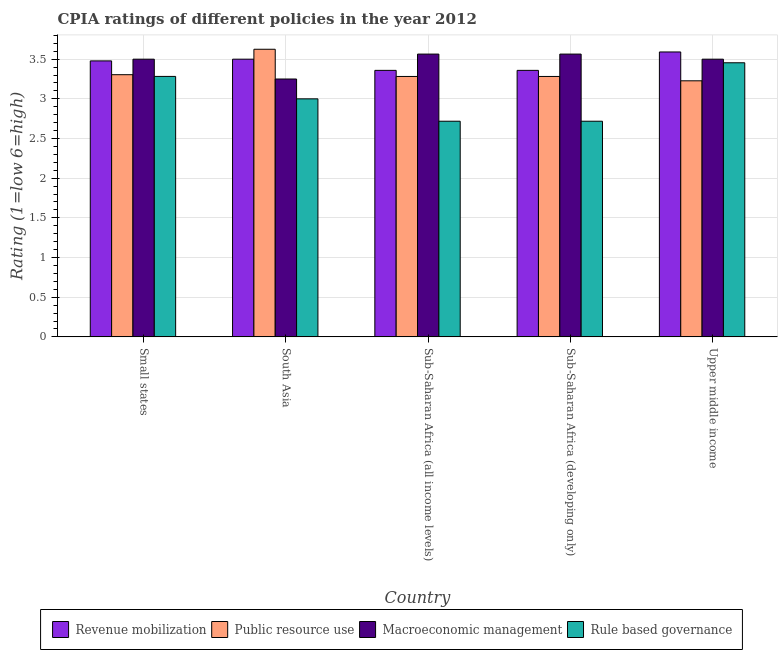How many different coloured bars are there?
Offer a very short reply. 4. How many groups of bars are there?
Ensure brevity in your answer.  5. Are the number of bars on each tick of the X-axis equal?
Make the answer very short. Yes. How many bars are there on the 2nd tick from the left?
Give a very brief answer. 4. What is the label of the 4th group of bars from the left?
Give a very brief answer. Sub-Saharan Africa (developing only). In how many cases, is the number of bars for a given country not equal to the number of legend labels?
Provide a short and direct response. 0. What is the cpia rating of macroeconomic management in Small states?
Make the answer very short. 3.5. Across all countries, what is the maximum cpia rating of macroeconomic management?
Your answer should be very brief. 3.56. Across all countries, what is the minimum cpia rating of revenue mobilization?
Your answer should be very brief. 3.36. In which country was the cpia rating of public resource use minimum?
Your answer should be compact. Upper middle income. What is the total cpia rating of macroeconomic management in the graph?
Keep it short and to the point. 17.38. What is the difference between the cpia rating of revenue mobilization in Small states and that in Sub-Saharan Africa (developing only)?
Your answer should be very brief. 0.12. What is the difference between the cpia rating of rule based governance in Small states and the cpia rating of public resource use in Sub-Saharan Africa (all income levels)?
Ensure brevity in your answer.  0. What is the average cpia rating of revenue mobilization per country?
Make the answer very short. 3.46. What is the ratio of the cpia rating of revenue mobilization in South Asia to that in Sub-Saharan Africa (developing only)?
Ensure brevity in your answer.  1.04. What is the difference between the highest and the second highest cpia rating of public resource use?
Provide a short and direct response. 0.32. What is the difference between the highest and the lowest cpia rating of public resource use?
Your answer should be very brief. 0.4. Is the sum of the cpia rating of rule based governance in South Asia and Upper middle income greater than the maximum cpia rating of macroeconomic management across all countries?
Provide a short and direct response. Yes. Is it the case that in every country, the sum of the cpia rating of public resource use and cpia rating of revenue mobilization is greater than the sum of cpia rating of rule based governance and cpia rating of macroeconomic management?
Provide a succinct answer. Yes. What does the 4th bar from the left in Sub-Saharan Africa (all income levels) represents?
Your answer should be very brief. Rule based governance. What does the 2nd bar from the right in South Asia represents?
Your response must be concise. Macroeconomic management. Is it the case that in every country, the sum of the cpia rating of revenue mobilization and cpia rating of public resource use is greater than the cpia rating of macroeconomic management?
Keep it short and to the point. Yes. How many bars are there?
Keep it short and to the point. 20. Are all the bars in the graph horizontal?
Provide a succinct answer. No. What is the title of the graph?
Your answer should be very brief. CPIA ratings of different policies in the year 2012. What is the label or title of the X-axis?
Your answer should be compact. Country. What is the Rating (1=low 6=high) in Revenue mobilization in Small states?
Give a very brief answer. 3.48. What is the Rating (1=low 6=high) in Public resource use in Small states?
Provide a short and direct response. 3.3. What is the Rating (1=low 6=high) of Rule based governance in Small states?
Your answer should be compact. 3.28. What is the Rating (1=low 6=high) in Revenue mobilization in South Asia?
Ensure brevity in your answer.  3.5. What is the Rating (1=low 6=high) in Public resource use in South Asia?
Your answer should be compact. 3.62. What is the Rating (1=low 6=high) of Macroeconomic management in South Asia?
Provide a short and direct response. 3.25. What is the Rating (1=low 6=high) of Revenue mobilization in Sub-Saharan Africa (all income levels)?
Your answer should be very brief. 3.36. What is the Rating (1=low 6=high) of Public resource use in Sub-Saharan Africa (all income levels)?
Offer a terse response. 3.28. What is the Rating (1=low 6=high) in Macroeconomic management in Sub-Saharan Africa (all income levels)?
Give a very brief answer. 3.56. What is the Rating (1=low 6=high) of Rule based governance in Sub-Saharan Africa (all income levels)?
Provide a short and direct response. 2.72. What is the Rating (1=low 6=high) of Revenue mobilization in Sub-Saharan Africa (developing only)?
Offer a very short reply. 3.36. What is the Rating (1=low 6=high) of Public resource use in Sub-Saharan Africa (developing only)?
Ensure brevity in your answer.  3.28. What is the Rating (1=low 6=high) in Macroeconomic management in Sub-Saharan Africa (developing only)?
Provide a short and direct response. 3.56. What is the Rating (1=low 6=high) in Rule based governance in Sub-Saharan Africa (developing only)?
Offer a very short reply. 2.72. What is the Rating (1=low 6=high) in Revenue mobilization in Upper middle income?
Provide a short and direct response. 3.59. What is the Rating (1=low 6=high) in Public resource use in Upper middle income?
Ensure brevity in your answer.  3.23. What is the Rating (1=low 6=high) of Rule based governance in Upper middle income?
Your response must be concise. 3.45. Across all countries, what is the maximum Rating (1=low 6=high) in Revenue mobilization?
Keep it short and to the point. 3.59. Across all countries, what is the maximum Rating (1=low 6=high) in Public resource use?
Ensure brevity in your answer.  3.62. Across all countries, what is the maximum Rating (1=low 6=high) in Macroeconomic management?
Offer a very short reply. 3.56. Across all countries, what is the maximum Rating (1=low 6=high) in Rule based governance?
Offer a terse response. 3.45. Across all countries, what is the minimum Rating (1=low 6=high) of Revenue mobilization?
Ensure brevity in your answer.  3.36. Across all countries, what is the minimum Rating (1=low 6=high) of Public resource use?
Make the answer very short. 3.23. Across all countries, what is the minimum Rating (1=low 6=high) in Rule based governance?
Your answer should be very brief. 2.72. What is the total Rating (1=low 6=high) of Revenue mobilization in the graph?
Make the answer very short. 17.29. What is the total Rating (1=low 6=high) of Public resource use in the graph?
Your answer should be compact. 16.72. What is the total Rating (1=low 6=high) of Macroeconomic management in the graph?
Your response must be concise. 17.38. What is the total Rating (1=low 6=high) in Rule based governance in the graph?
Keep it short and to the point. 15.17. What is the difference between the Rating (1=low 6=high) of Revenue mobilization in Small states and that in South Asia?
Ensure brevity in your answer.  -0.02. What is the difference between the Rating (1=low 6=high) in Public resource use in Small states and that in South Asia?
Ensure brevity in your answer.  -0.32. What is the difference between the Rating (1=low 6=high) of Rule based governance in Small states and that in South Asia?
Your answer should be compact. 0.28. What is the difference between the Rating (1=low 6=high) of Revenue mobilization in Small states and that in Sub-Saharan Africa (all income levels)?
Your response must be concise. 0.12. What is the difference between the Rating (1=low 6=high) in Public resource use in Small states and that in Sub-Saharan Africa (all income levels)?
Provide a succinct answer. 0.02. What is the difference between the Rating (1=low 6=high) of Macroeconomic management in Small states and that in Sub-Saharan Africa (all income levels)?
Your answer should be very brief. -0.06. What is the difference between the Rating (1=low 6=high) of Rule based governance in Small states and that in Sub-Saharan Africa (all income levels)?
Your answer should be compact. 0.56. What is the difference between the Rating (1=low 6=high) in Revenue mobilization in Small states and that in Sub-Saharan Africa (developing only)?
Your answer should be very brief. 0.12. What is the difference between the Rating (1=low 6=high) of Public resource use in Small states and that in Sub-Saharan Africa (developing only)?
Make the answer very short. 0.02. What is the difference between the Rating (1=low 6=high) of Macroeconomic management in Small states and that in Sub-Saharan Africa (developing only)?
Give a very brief answer. -0.06. What is the difference between the Rating (1=low 6=high) in Rule based governance in Small states and that in Sub-Saharan Africa (developing only)?
Keep it short and to the point. 0.56. What is the difference between the Rating (1=low 6=high) in Revenue mobilization in Small states and that in Upper middle income?
Your answer should be very brief. -0.11. What is the difference between the Rating (1=low 6=high) of Public resource use in Small states and that in Upper middle income?
Ensure brevity in your answer.  0.08. What is the difference between the Rating (1=low 6=high) in Macroeconomic management in Small states and that in Upper middle income?
Provide a short and direct response. 0. What is the difference between the Rating (1=low 6=high) in Rule based governance in Small states and that in Upper middle income?
Your answer should be very brief. -0.17. What is the difference between the Rating (1=low 6=high) of Revenue mobilization in South Asia and that in Sub-Saharan Africa (all income levels)?
Ensure brevity in your answer.  0.14. What is the difference between the Rating (1=low 6=high) in Public resource use in South Asia and that in Sub-Saharan Africa (all income levels)?
Offer a very short reply. 0.34. What is the difference between the Rating (1=low 6=high) in Macroeconomic management in South Asia and that in Sub-Saharan Africa (all income levels)?
Your answer should be compact. -0.31. What is the difference between the Rating (1=low 6=high) of Rule based governance in South Asia and that in Sub-Saharan Africa (all income levels)?
Offer a terse response. 0.28. What is the difference between the Rating (1=low 6=high) in Revenue mobilization in South Asia and that in Sub-Saharan Africa (developing only)?
Provide a succinct answer. 0.14. What is the difference between the Rating (1=low 6=high) in Public resource use in South Asia and that in Sub-Saharan Africa (developing only)?
Provide a short and direct response. 0.34. What is the difference between the Rating (1=low 6=high) in Macroeconomic management in South Asia and that in Sub-Saharan Africa (developing only)?
Make the answer very short. -0.31. What is the difference between the Rating (1=low 6=high) of Rule based governance in South Asia and that in Sub-Saharan Africa (developing only)?
Keep it short and to the point. 0.28. What is the difference between the Rating (1=low 6=high) in Revenue mobilization in South Asia and that in Upper middle income?
Provide a short and direct response. -0.09. What is the difference between the Rating (1=low 6=high) in Public resource use in South Asia and that in Upper middle income?
Ensure brevity in your answer.  0.4. What is the difference between the Rating (1=low 6=high) in Rule based governance in South Asia and that in Upper middle income?
Provide a short and direct response. -0.45. What is the difference between the Rating (1=low 6=high) in Revenue mobilization in Sub-Saharan Africa (all income levels) and that in Sub-Saharan Africa (developing only)?
Provide a succinct answer. 0. What is the difference between the Rating (1=low 6=high) in Public resource use in Sub-Saharan Africa (all income levels) and that in Sub-Saharan Africa (developing only)?
Provide a succinct answer. 0. What is the difference between the Rating (1=low 6=high) of Rule based governance in Sub-Saharan Africa (all income levels) and that in Sub-Saharan Africa (developing only)?
Make the answer very short. 0. What is the difference between the Rating (1=low 6=high) in Revenue mobilization in Sub-Saharan Africa (all income levels) and that in Upper middle income?
Make the answer very short. -0.23. What is the difference between the Rating (1=low 6=high) in Public resource use in Sub-Saharan Africa (all income levels) and that in Upper middle income?
Provide a succinct answer. 0.05. What is the difference between the Rating (1=low 6=high) in Macroeconomic management in Sub-Saharan Africa (all income levels) and that in Upper middle income?
Your answer should be very brief. 0.06. What is the difference between the Rating (1=low 6=high) of Rule based governance in Sub-Saharan Africa (all income levels) and that in Upper middle income?
Give a very brief answer. -0.74. What is the difference between the Rating (1=low 6=high) in Revenue mobilization in Sub-Saharan Africa (developing only) and that in Upper middle income?
Provide a short and direct response. -0.23. What is the difference between the Rating (1=low 6=high) in Public resource use in Sub-Saharan Africa (developing only) and that in Upper middle income?
Make the answer very short. 0.05. What is the difference between the Rating (1=low 6=high) in Macroeconomic management in Sub-Saharan Africa (developing only) and that in Upper middle income?
Provide a succinct answer. 0.06. What is the difference between the Rating (1=low 6=high) of Rule based governance in Sub-Saharan Africa (developing only) and that in Upper middle income?
Ensure brevity in your answer.  -0.74. What is the difference between the Rating (1=low 6=high) in Revenue mobilization in Small states and the Rating (1=low 6=high) in Public resource use in South Asia?
Your response must be concise. -0.15. What is the difference between the Rating (1=low 6=high) in Revenue mobilization in Small states and the Rating (1=low 6=high) in Macroeconomic management in South Asia?
Your answer should be compact. 0.23. What is the difference between the Rating (1=low 6=high) of Revenue mobilization in Small states and the Rating (1=low 6=high) of Rule based governance in South Asia?
Your answer should be very brief. 0.48. What is the difference between the Rating (1=low 6=high) of Public resource use in Small states and the Rating (1=low 6=high) of Macroeconomic management in South Asia?
Ensure brevity in your answer.  0.05. What is the difference between the Rating (1=low 6=high) in Public resource use in Small states and the Rating (1=low 6=high) in Rule based governance in South Asia?
Your answer should be compact. 0.3. What is the difference between the Rating (1=low 6=high) of Macroeconomic management in Small states and the Rating (1=low 6=high) of Rule based governance in South Asia?
Make the answer very short. 0.5. What is the difference between the Rating (1=low 6=high) in Revenue mobilization in Small states and the Rating (1=low 6=high) in Public resource use in Sub-Saharan Africa (all income levels)?
Your response must be concise. 0.2. What is the difference between the Rating (1=low 6=high) in Revenue mobilization in Small states and the Rating (1=low 6=high) in Macroeconomic management in Sub-Saharan Africa (all income levels)?
Make the answer very short. -0.09. What is the difference between the Rating (1=low 6=high) of Revenue mobilization in Small states and the Rating (1=low 6=high) of Rule based governance in Sub-Saharan Africa (all income levels)?
Your answer should be compact. 0.76. What is the difference between the Rating (1=low 6=high) in Public resource use in Small states and the Rating (1=low 6=high) in Macroeconomic management in Sub-Saharan Africa (all income levels)?
Provide a short and direct response. -0.26. What is the difference between the Rating (1=low 6=high) in Public resource use in Small states and the Rating (1=low 6=high) in Rule based governance in Sub-Saharan Africa (all income levels)?
Ensure brevity in your answer.  0.59. What is the difference between the Rating (1=low 6=high) in Macroeconomic management in Small states and the Rating (1=low 6=high) in Rule based governance in Sub-Saharan Africa (all income levels)?
Provide a succinct answer. 0.78. What is the difference between the Rating (1=low 6=high) of Revenue mobilization in Small states and the Rating (1=low 6=high) of Public resource use in Sub-Saharan Africa (developing only)?
Your response must be concise. 0.2. What is the difference between the Rating (1=low 6=high) in Revenue mobilization in Small states and the Rating (1=low 6=high) in Macroeconomic management in Sub-Saharan Africa (developing only)?
Ensure brevity in your answer.  -0.09. What is the difference between the Rating (1=low 6=high) of Revenue mobilization in Small states and the Rating (1=low 6=high) of Rule based governance in Sub-Saharan Africa (developing only)?
Offer a terse response. 0.76. What is the difference between the Rating (1=low 6=high) in Public resource use in Small states and the Rating (1=low 6=high) in Macroeconomic management in Sub-Saharan Africa (developing only)?
Provide a succinct answer. -0.26. What is the difference between the Rating (1=low 6=high) of Public resource use in Small states and the Rating (1=low 6=high) of Rule based governance in Sub-Saharan Africa (developing only)?
Make the answer very short. 0.59. What is the difference between the Rating (1=low 6=high) in Macroeconomic management in Small states and the Rating (1=low 6=high) in Rule based governance in Sub-Saharan Africa (developing only)?
Ensure brevity in your answer.  0.78. What is the difference between the Rating (1=low 6=high) of Revenue mobilization in Small states and the Rating (1=low 6=high) of Public resource use in Upper middle income?
Keep it short and to the point. 0.25. What is the difference between the Rating (1=low 6=high) of Revenue mobilization in Small states and the Rating (1=low 6=high) of Macroeconomic management in Upper middle income?
Keep it short and to the point. -0.02. What is the difference between the Rating (1=low 6=high) of Revenue mobilization in Small states and the Rating (1=low 6=high) of Rule based governance in Upper middle income?
Give a very brief answer. 0.02. What is the difference between the Rating (1=low 6=high) of Public resource use in Small states and the Rating (1=low 6=high) of Macroeconomic management in Upper middle income?
Make the answer very short. -0.2. What is the difference between the Rating (1=low 6=high) in Public resource use in Small states and the Rating (1=low 6=high) in Rule based governance in Upper middle income?
Provide a succinct answer. -0.15. What is the difference between the Rating (1=low 6=high) in Macroeconomic management in Small states and the Rating (1=low 6=high) in Rule based governance in Upper middle income?
Provide a succinct answer. 0.05. What is the difference between the Rating (1=low 6=high) of Revenue mobilization in South Asia and the Rating (1=low 6=high) of Public resource use in Sub-Saharan Africa (all income levels)?
Offer a very short reply. 0.22. What is the difference between the Rating (1=low 6=high) of Revenue mobilization in South Asia and the Rating (1=low 6=high) of Macroeconomic management in Sub-Saharan Africa (all income levels)?
Your answer should be very brief. -0.06. What is the difference between the Rating (1=low 6=high) in Revenue mobilization in South Asia and the Rating (1=low 6=high) in Rule based governance in Sub-Saharan Africa (all income levels)?
Provide a short and direct response. 0.78. What is the difference between the Rating (1=low 6=high) in Public resource use in South Asia and the Rating (1=low 6=high) in Macroeconomic management in Sub-Saharan Africa (all income levels)?
Make the answer very short. 0.06. What is the difference between the Rating (1=low 6=high) in Public resource use in South Asia and the Rating (1=low 6=high) in Rule based governance in Sub-Saharan Africa (all income levels)?
Give a very brief answer. 0.91. What is the difference between the Rating (1=low 6=high) of Macroeconomic management in South Asia and the Rating (1=low 6=high) of Rule based governance in Sub-Saharan Africa (all income levels)?
Your answer should be compact. 0.53. What is the difference between the Rating (1=low 6=high) of Revenue mobilization in South Asia and the Rating (1=low 6=high) of Public resource use in Sub-Saharan Africa (developing only)?
Offer a terse response. 0.22. What is the difference between the Rating (1=low 6=high) of Revenue mobilization in South Asia and the Rating (1=low 6=high) of Macroeconomic management in Sub-Saharan Africa (developing only)?
Your response must be concise. -0.06. What is the difference between the Rating (1=low 6=high) of Revenue mobilization in South Asia and the Rating (1=low 6=high) of Rule based governance in Sub-Saharan Africa (developing only)?
Your answer should be very brief. 0.78. What is the difference between the Rating (1=low 6=high) in Public resource use in South Asia and the Rating (1=low 6=high) in Macroeconomic management in Sub-Saharan Africa (developing only)?
Keep it short and to the point. 0.06. What is the difference between the Rating (1=low 6=high) in Public resource use in South Asia and the Rating (1=low 6=high) in Rule based governance in Sub-Saharan Africa (developing only)?
Make the answer very short. 0.91. What is the difference between the Rating (1=low 6=high) of Macroeconomic management in South Asia and the Rating (1=low 6=high) of Rule based governance in Sub-Saharan Africa (developing only)?
Offer a very short reply. 0.53. What is the difference between the Rating (1=low 6=high) in Revenue mobilization in South Asia and the Rating (1=low 6=high) in Public resource use in Upper middle income?
Provide a short and direct response. 0.27. What is the difference between the Rating (1=low 6=high) of Revenue mobilization in South Asia and the Rating (1=low 6=high) of Rule based governance in Upper middle income?
Offer a very short reply. 0.05. What is the difference between the Rating (1=low 6=high) of Public resource use in South Asia and the Rating (1=low 6=high) of Macroeconomic management in Upper middle income?
Offer a terse response. 0.12. What is the difference between the Rating (1=low 6=high) in Public resource use in South Asia and the Rating (1=low 6=high) in Rule based governance in Upper middle income?
Give a very brief answer. 0.17. What is the difference between the Rating (1=low 6=high) of Macroeconomic management in South Asia and the Rating (1=low 6=high) of Rule based governance in Upper middle income?
Your answer should be compact. -0.2. What is the difference between the Rating (1=low 6=high) in Revenue mobilization in Sub-Saharan Africa (all income levels) and the Rating (1=low 6=high) in Public resource use in Sub-Saharan Africa (developing only)?
Your answer should be compact. 0.08. What is the difference between the Rating (1=low 6=high) of Revenue mobilization in Sub-Saharan Africa (all income levels) and the Rating (1=low 6=high) of Macroeconomic management in Sub-Saharan Africa (developing only)?
Your answer should be compact. -0.21. What is the difference between the Rating (1=low 6=high) of Revenue mobilization in Sub-Saharan Africa (all income levels) and the Rating (1=low 6=high) of Rule based governance in Sub-Saharan Africa (developing only)?
Your response must be concise. 0.64. What is the difference between the Rating (1=low 6=high) in Public resource use in Sub-Saharan Africa (all income levels) and the Rating (1=low 6=high) in Macroeconomic management in Sub-Saharan Africa (developing only)?
Provide a succinct answer. -0.28. What is the difference between the Rating (1=low 6=high) of Public resource use in Sub-Saharan Africa (all income levels) and the Rating (1=low 6=high) of Rule based governance in Sub-Saharan Africa (developing only)?
Keep it short and to the point. 0.56. What is the difference between the Rating (1=low 6=high) of Macroeconomic management in Sub-Saharan Africa (all income levels) and the Rating (1=low 6=high) of Rule based governance in Sub-Saharan Africa (developing only)?
Offer a very short reply. 0.85. What is the difference between the Rating (1=low 6=high) in Revenue mobilization in Sub-Saharan Africa (all income levels) and the Rating (1=low 6=high) in Public resource use in Upper middle income?
Offer a very short reply. 0.13. What is the difference between the Rating (1=low 6=high) of Revenue mobilization in Sub-Saharan Africa (all income levels) and the Rating (1=low 6=high) of Macroeconomic management in Upper middle income?
Keep it short and to the point. -0.14. What is the difference between the Rating (1=low 6=high) in Revenue mobilization in Sub-Saharan Africa (all income levels) and the Rating (1=low 6=high) in Rule based governance in Upper middle income?
Keep it short and to the point. -0.1. What is the difference between the Rating (1=low 6=high) of Public resource use in Sub-Saharan Africa (all income levels) and the Rating (1=low 6=high) of Macroeconomic management in Upper middle income?
Offer a terse response. -0.22. What is the difference between the Rating (1=low 6=high) of Public resource use in Sub-Saharan Africa (all income levels) and the Rating (1=low 6=high) of Rule based governance in Upper middle income?
Provide a short and direct response. -0.17. What is the difference between the Rating (1=low 6=high) of Macroeconomic management in Sub-Saharan Africa (all income levels) and the Rating (1=low 6=high) of Rule based governance in Upper middle income?
Ensure brevity in your answer.  0.11. What is the difference between the Rating (1=low 6=high) of Revenue mobilization in Sub-Saharan Africa (developing only) and the Rating (1=low 6=high) of Public resource use in Upper middle income?
Provide a short and direct response. 0.13. What is the difference between the Rating (1=low 6=high) of Revenue mobilization in Sub-Saharan Africa (developing only) and the Rating (1=low 6=high) of Macroeconomic management in Upper middle income?
Keep it short and to the point. -0.14. What is the difference between the Rating (1=low 6=high) in Revenue mobilization in Sub-Saharan Africa (developing only) and the Rating (1=low 6=high) in Rule based governance in Upper middle income?
Provide a succinct answer. -0.1. What is the difference between the Rating (1=low 6=high) of Public resource use in Sub-Saharan Africa (developing only) and the Rating (1=low 6=high) of Macroeconomic management in Upper middle income?
Keep it short and to the point. -0.22. What is the difference between the Rating (1=low 6=high) of Public resource use in Sub-Saharan Africa (developing only) and the Rating (1=low 6=high) of Rule based governance in Upper middle income?
Give a very brief answer. -0.17. What is the difference between the Rating (1=low 6=high) in Macroeconomic management in Sub-Saharan Africa (developing only) and the Rating (1=low 6=high) in Rule based governance in Upper middle income?
Make the answer very short. 0.11. What is the average Rating (1=low 6=high) in Revenue mobilization per country?
Provide a short and direct response. 3.46. What is the average Rating (1=low 6=high) of Public resource use per country?
Your answer should be very brief. 3.34. What is the average Rating (1=low 6=high) in Macroeconomic management per country?
Provide a short and direct response. 3.48. What is the average Rating (1=low 6=high) in Rule based governance per country?
Your response must be concise. 3.03. What is the difference between the Rating (1=low 6=high) in Revenue mobilization and Rating (1=low 6=high) in Public resource use in Small states?
Ensure brevity in your answer.  0.17. What is the difference between the Rating (1=low 6=high) in Revenue mobilization and Rating (1=low 6=high) in Macroeconomic management in Small states?
Your answer should be very brief. -0.02. What is the difference between the Rating (1=low 6=high) of Revenue mobilization and Rating (1=low 6=high) of Rule based governance in Small states?
Give a very brief answer. 0.2. What is the difference between the Rating (1=low 6=high) in Public resource use and Rating (1=low 6=high) in Macroeconomic management in Small states?
Keep it short and to the point. -0.2. What is the difference between the Rating (1=low 6=high) in Public resource use and Rating (1=low 6=high) in Rule based governance in Small states?
Provide a short and direct response. 0.02. What is the difference between the Rating (1=low 6=high) in Macroeconomic management and Rating (1=low 6=high) in Rule based governance in Small states?
Offer a very short reply. 0.22. What is the difference between the Rating (1=low 6=high) of Revenue mobilization and Rating (1=low 6=high) of Public resource use in South Asia?
Make the answer very short. -0.12. What is the difference between the Rating (1=low 6=high) in Revenue mobilization and Rating (1=low 6=high) in Macroeconomic management in South Asia?
Ensure brevity in your answer.  0.25. What is the difference between the Rating (1=low 6=high) in Revenue mobilization and Rating (1=low 6=high) in Rule based governance in South Asia?
Provide a short and direct response. 0.5. What is the difference between the Rating (1=low 6=high) in Public resource use and Rating (1=low 6=high) in Macroeconomic management in South Asia?
Your answer should be compact. 0.38. What is the difference between the Rating (1=low 6=high) in Revenue mobilization and Rating (1=low 6=high) in Public resource use in Sub-Saharan Africa (all income levels)?
Provide a short and direct response. 0.08. What is the difference between the Rating (1=low 6=high) in Revenue mobilization and Rating (1=low 6=high) in Macroeconomic management in Sub-Saharan Africa (all income levels)?
Offer a terse response. -0.21. What is the difference between the Rating (1=low 6=high) of Revenue mobilization and Rating (1=low 6=high) of Rule based governance in Sub-Saharan Africa (all income levels)?
Your response must be concise. 0.64. What is the difference between the Rating (1=low 6=high) in Public resource use and Rating (1=low 6=high) in Macroeconomic management in Sub-Saharan Africa (all income levels)?
Offer a terse response. -0.28. What is the difference between the Rating (1=low 6=high) of Public resource use and Rating (1=low 6=high) of Rule based governance in Sub-Saharan Africa (all income levels)?
Provide a short and direct response. 0.56. What is the difference between the Rating (1=low 6=high) in Macroeconomic management and Rating (1=low 6=high) in Rule based governance in Sub-Saharan Africa (all income levels)?
Provide a short and direct response. 0.85. What is the difference between the Rating (1=low 6=high) in Revenue mobilization and Rating (1=low 6=high) in Public resource use in Sub-Saharan Africa (developing only)?
Your response must be concise. 0.08. What is the difference between the Rating (1=low 6=high) of Revenue mobilization and Rating (1=low 6=high) of Macroeconomic management in Sub-Saharan Africa (developing only)?
Ensure brevity in your answer.  -0.21. What is the difference between the Rating (1=low 6=high) of Revenue mobilization and Rating (1=low 6=high) of Rule based governance in Sub-Saharan Africa (developing only)?
Offer a very short reply. 0.64. What is the difference between the Rating (1=low 6=high) in Public resource use and Rating (1=low 6=high) in Macroeconomic management in Sub-Saharan Africa (developing only)?
Your answer should be compact. -0.28. What is the difference between the Rating (1=low 6=high) of Public resource use and Rating (1=low 6=high) of Rule based governance in Sub-Saharan Africa (developing only)?
Give a very brief answer. 0.56. What is the difference between the Rating (1=low 6=high) of Macroeconomic management and Rating (1=low 6=high) of Rule based governance in Sub-Saharan Africa (developing only)?
Offer a very short reply. 0.85. What is the difference between the Rating (1=low 6=high) in Revenue mobilization and Rating (1=low 6=high) in Public resource use in Upper middle income?
Provide a short and direct response. 0.36. What is the difference between the Rating (1=low 6=high) of Revenue mobilization and Rating (1=low 6=high) of Macroeconomic management in Upper middle income?
Your response must be concise. 0.09. What is the difference between the Rating (1=low 6=high) in Revenue mobilization and Rating (1=low 6=high) in Rule based governance in Upper middle income?
Ensure brevity in your answer.  0.14. What is the difference between the Rating (1=low 6=high) of Public resource use and Rating (1=low 6=high) of Macroeconomic management in Upper middle income?
Your response must be concise. -0.27. What is the difference between the Rating (1=low 6=high) in Public resource use and Rating (1=low 6=high) in Rule based governance in Upper middle income?
Make the answer very short. -0.23. What is the difference between the Rating (1=low 6=high) of Macroeconomic management and Rating (1=low 6=high) of Rule based governance in Upper middle income?
Your response must be concise. 0.05. What is the ratio of the Rating (1=low 6=high) of Public resource use in Small states to that in South Asia?
Give a very brief answer. 0.91. What is the ratio of the Rating (1=low 6=high) of Macroeconomic management in Small states to that in South Asia?
Offer a very short reply. 1.08. What is the ratio of the Rating (1=low 6=high) of Rule based governance in Small states to that in South Asia?
Your answer should be very brief. 1.09. What is the ratio of the Rating (1=low 6=high) in Revenue mobilization in Small states to that in Sub-Saharan Africa (all income levels)?
Ensure brevity in your answer.  1.04. What is the ratio of the Rating (1=low 6=high) of Public resource use in Small states to that in Sub-Saharan Africa (all income levels)?
Offer a very short reply. 1.01. What is the ratio of the Rating (1=low 6=high) of Macroeconomic management in Small states to that in Sub-Saharan Africa (all income levels)?
Your response must be concise. 0.98. What is the ratio of the Rating (1=low 6=high) in Rule based governance in Small states to that in Sub-Saharan Africa (all income levels)?
Your answer should be compact. 1.21. What is the ratio of the Rating (1=low 6=high) of Revenue mobilization in Small states to that in Sub-Saharan Africa (developing only)?
Provide a succinct answer. 1.04. What is the ratio of the Rating (1=low 6=high) of Public resource use in Small states to that in Sub-Saharan Africa (developing only)?
Keep it short and to the point. 1.01. What is the ratio of the Rating (1=low 6=high) in Rule based governance in Small states to that in Sub-Saharan Africa (developing only)?
Ensure brevity in your answer.  1.21. What is the ratio of the Rating (1=low 6=high) in Revenue mobilization in Small states to that in Upper middle income?
Your response must be concise. 0.97. What is the ratio of the Rating (1=low 6=high) in Public resource use in Small states to that in Upper middle income?
Ensure brevity in your answer.  1.02. What is the ratio of the Rating (1=low 6=high) of Rule based governance in Small states to that in Upper middle income?
Keep it short and to the point. 0.95. What is the ratio of the Rating (1=low 6=high) of Revenue mobilization in South Asia to that in Sub-Saharan Africa (all income levels)?
Give a very brief answer. 1.04. What is the ratio of the Rating (1=low 6=high) of Public resource use in South Asia to that in Sub-Saharan Africa (all income levels)?
Offer a very short reply. 1.1. What is the ratio of the Rating (1=low 6=high) in Macroeconomic management in South Asia to that in Sub-Saharan Africa (all income levels)?
Offer a very short reply. 0.91. What is the ratio of the Rating (1=low 6=high) in Rule based governance in South Asia to that in Sub-Saharan Africa (all income levels)?
Keep it short and to the point. 1.1. What is the ratio of the Rating (1=low 6=high) in Revenue mobilization in South Asia to that in Sub-Saharan Africa (developing only)?
Your response must be concise. 1.04. What is the ratio of the Rating (1=low 6=high) of Public resource use in South Asia to that in Sub-Saharan Africa (developing only)?
Provide a short and direct response. 1.1. What is the ratio of the Rating (1=low 6=high) in Macroeconomic management in South Asia to that in Sub-Saharan Africa (developing only)?
Provide a succinct answer. 0.91. What is the ratio of the Rating (1=low 6=high) of Rule based governance in South Asia to that in Sub-Saharan Africa (developing only)?
Provide a short and direct response. 1.1. What is the ratio of the Rating (1=low 6=high) of Revenue mobilization in South Asia to that in Upper middle income?
Your answer should be very brief. 0.97. What is the ratio of the Rating (1=low 6=high) of Public resource use in South Asia to that in Upper middle income?
Make the answer very short. 1.12. What is the ratio of the Rating (1=low 6=high) in Rule based governance in South Asia to that in Upper middle income?
Your response must be concise. 0.87. What is the ratio of the Rating (1=low 6=high) of Revenue mobilization in Sub-Saharan Africa (all income levels) to that in Sub-Saharan Africa (developing only)?
Offer a terse response. 1. What is the ratio of the Rating (1=low 6=high) of Public resource use in Sub-Saharan Africa (all income levels) to that in Sub-Saharan Africa (developing only)?
Make the answer very short. 1. What is the ratio of the Rating (1=low 6=high) of Macroeconomic management in Sub-Saharan Africa (all income levels) to that in Sub-Saharan Africa (developing only)?
Provide a succinct answer. 1. What is the ratio of the Rating (1=low 6=high) in Revenue mobilization in Sub-Saharan Africa (all income levels) to that in Upper middle income?
Your answer should be very brief. 0.94. What is the ratio of the Rating (1=low 6=high) in Public resource use in Sub-Saharan Africa (all income levels) to that in Upper middle income?
Your answer should be compact. 1.02. What is the ratio of the Rating (1=low 6=high) in Macroeconomic management in Sub-Saharan Africa (all income levels) to that in Upper middle income?
Make the answer very short. 1.02. What is the ratio of the Rating (1=low 6=high) in Rule based governance in Sub-Saharan Africa (all income levels) to that in Upper middle income?
Provide a short and direct response. 0.79. What is the ratio of the Rating (1=low 6=high) of Revenue mobilization in Sub-Saharan Africa (developing only) to that in Upper middle income?
Your response must be concise. 0.94. What is the ratio of the Rating (1=low 6=high) in Public resource use in Sub-Saharan Africa (developing only) to that in Upper middle income?
Offer a very short reply. 1.02. What is the ratio of the Rating (1=low 6=high) in Macroeconomic management in Sub-Saharan Africa (developing only) to that in Upper middle income?
Your answer should be very brief. 1.02. What is the ratio of the Rating (1=low 6=high) of Rule based governance in Sub-Saharan Africa (developing only) to that in Upper middle income?
Offer a very short reply. 0.79. What is the difference between the highest and the second highest Rating (1=low 6=high) of Revenue mobilization?
Your response must be concise. 0.09. What is the difference between the highest and the second highest Rating (1=low 6=high) in Public resource use?
Your answer should be very brief. 0.32. What is the difference between the highest and the second highest Rating (1=low 6=high) of Rule based governance?
Ensure brevity in your answer.  0.17. What is the difference between the highest and the lowest Rating (1=low 6=high) in Revenue mobilization?
Give a very brief answer. 0.23. What is the difference between the highest and the lowest Rating (1=low 6=high) in Public resource use?
Make the answer very short. 0.4. What is the difference between the highest and the lowest Rating (1=low 6=high) in Macroeconomic management?
Keep it short and to the point. 0.31. What is the difference between the highest and the lowest Rating (1=low 6=high) in Rule based governance?
Your answer should be compact. 0.74. 